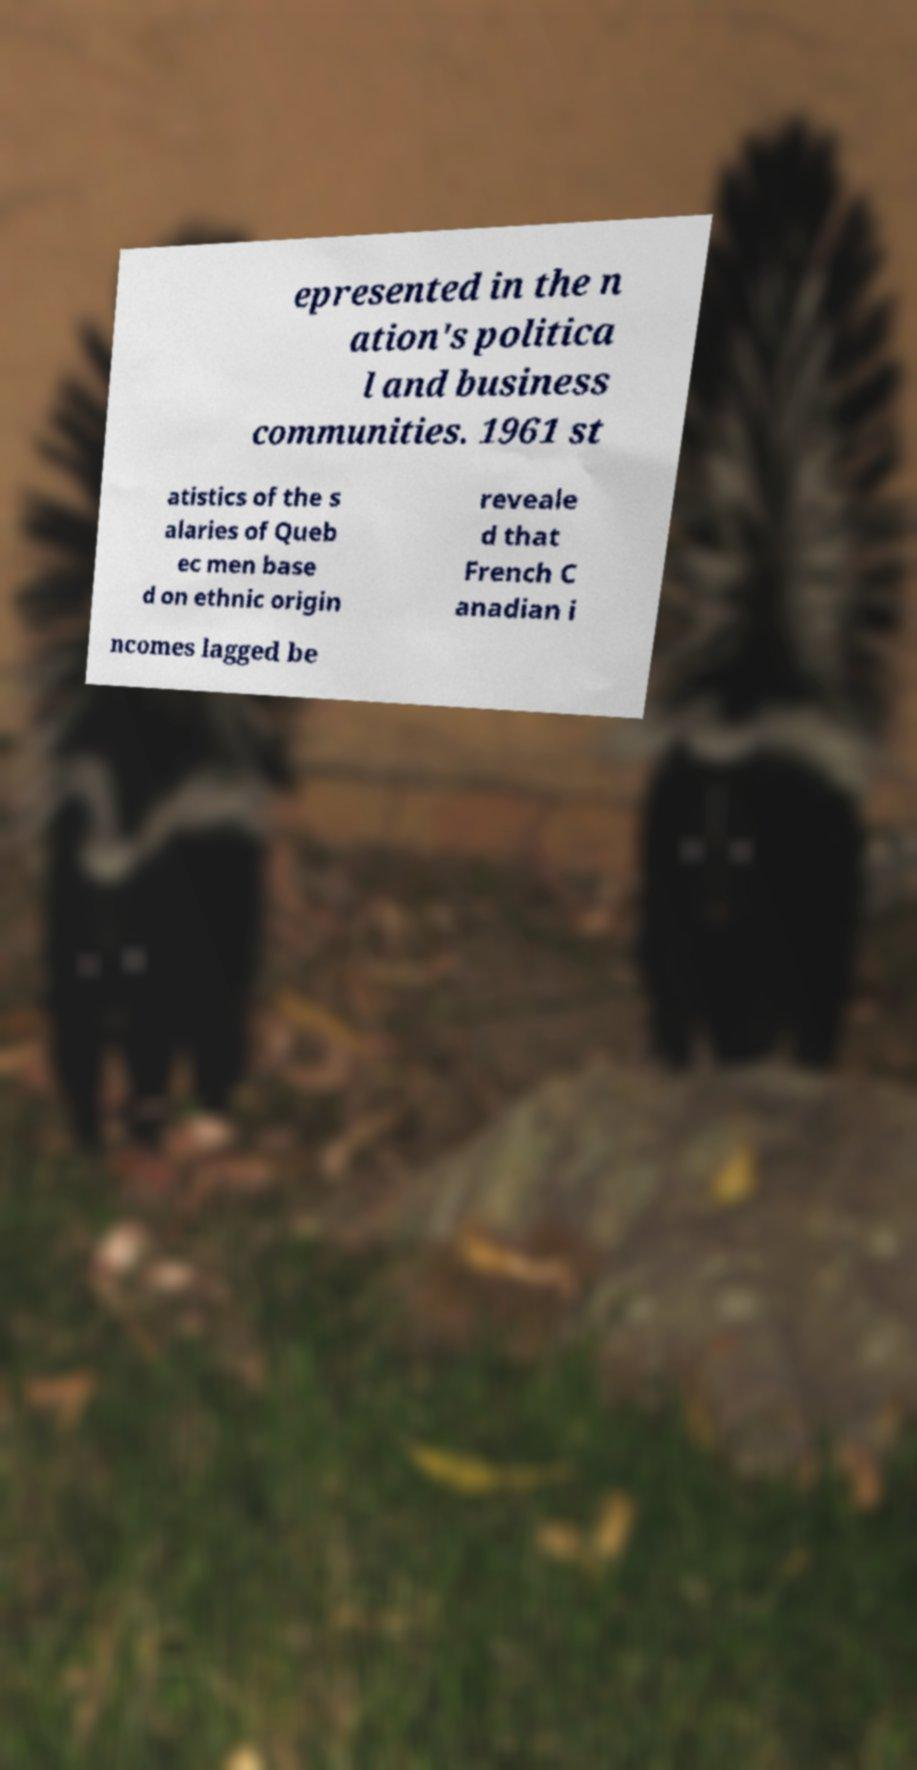Please read and relay the text visible in this image. What does it say? epresented in the n ation's politica l and business communities. 1961 st atistics of the s alaries of Queb ec men base d on ethnic origin reveale d that French C anadian i ncomes lagged be 